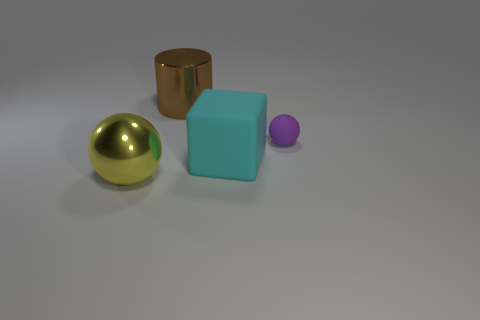Add 3 gray metal things. How many objects exist? 7 Subtract all cylinders. How many objects are left? 3 Subtract all gray blocks. Subtract all brown cylinders. How many blocks are left? 1 Subtract all gray blocks. How many purple balls are left? 1 Subtract all yellow balls. Subtract all large metallic objects. How many objects are left? 1 Add 1 metal cylinders. How many metal cylinders are left? 2 Add 2 large metallic balls. How many large metallic balls exist? 3 Subtract 0 brown blocks. How many objects are left? 4 